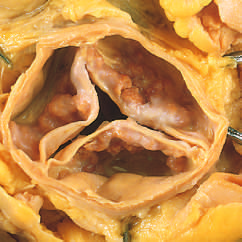what are not fused, as in rheumatic aortic valve stenosis?
Answer the question using a single word or phrase. The commissures 